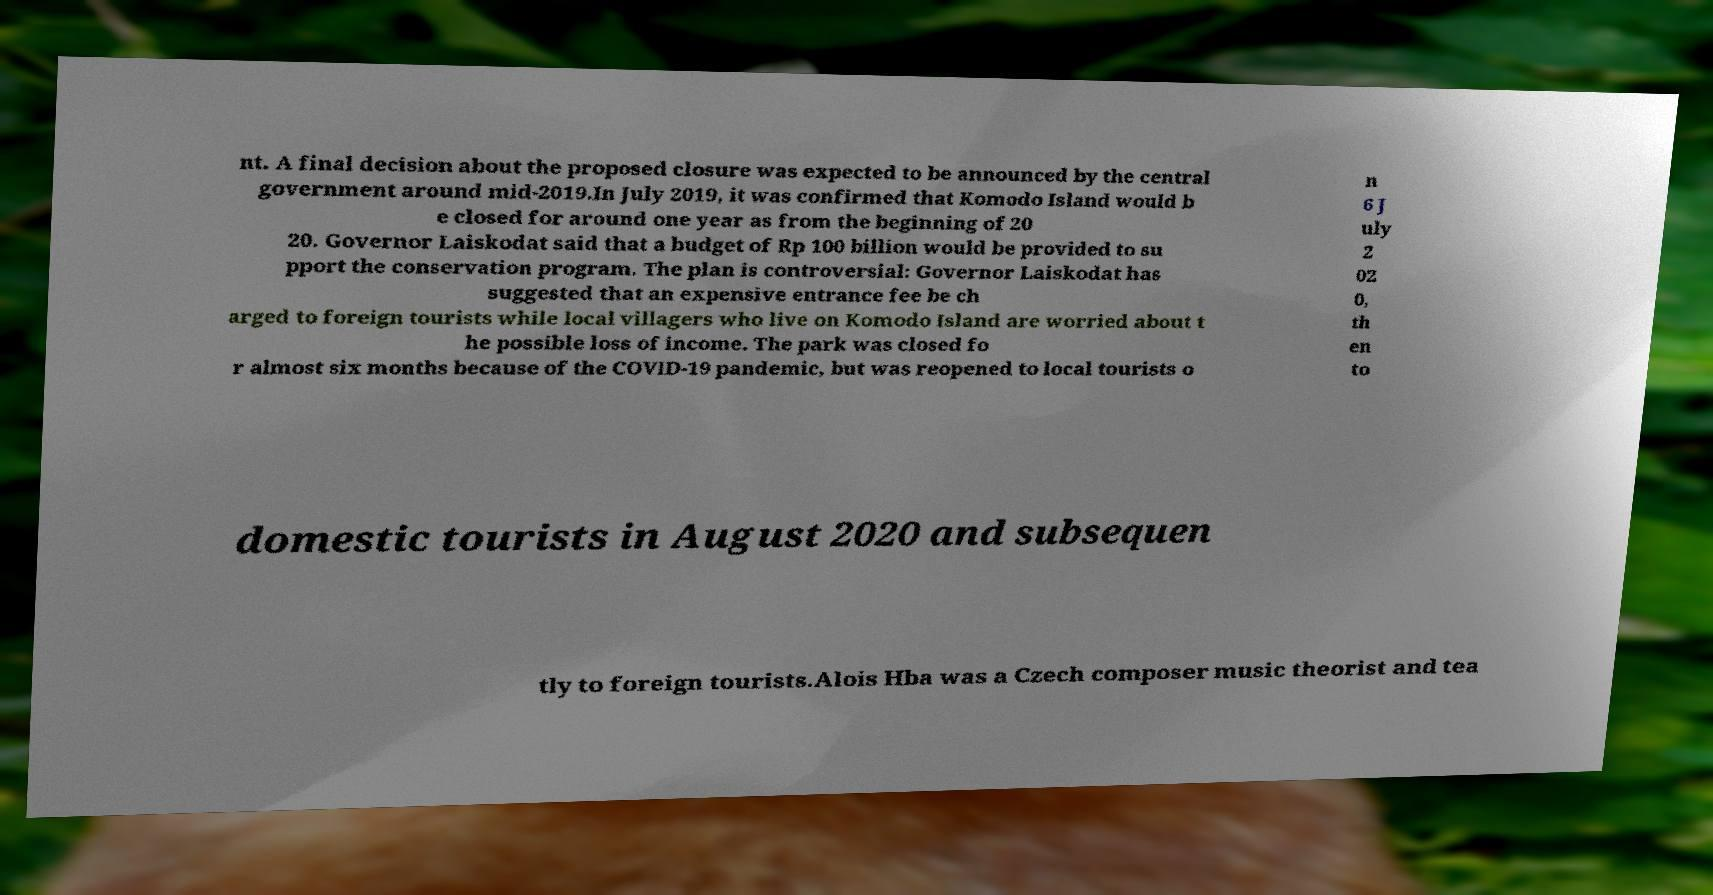What messages or text are displayed in this image? I need them in a readable, typed format. nt. A final decision about the proposed closure was expected to be announced by the central government around mid-2019.In July 2019, it was confirmed that Komodo Island would b e closed for around one year as from the beginning of 20 20. Governor Laiskodat said that a budget of Rp 100 billion would be provided to su pport the conservation program. The plan is controversial: Governor Laiskodat has suggested that an expensive entrance fee be ch arged to foreign tourists while local villagers who live on Komodo Island are worried about t he possible loss of income. The park was closed fo r almost six months because of the COVID-19 pandemic, but was reopened to local tourists o n 6 J uly 2 02 0, th en to domestic tourists in August 2020 and subsequen tly to foreign tourists.Alois Hba was a Czech composer music theorist and tea 